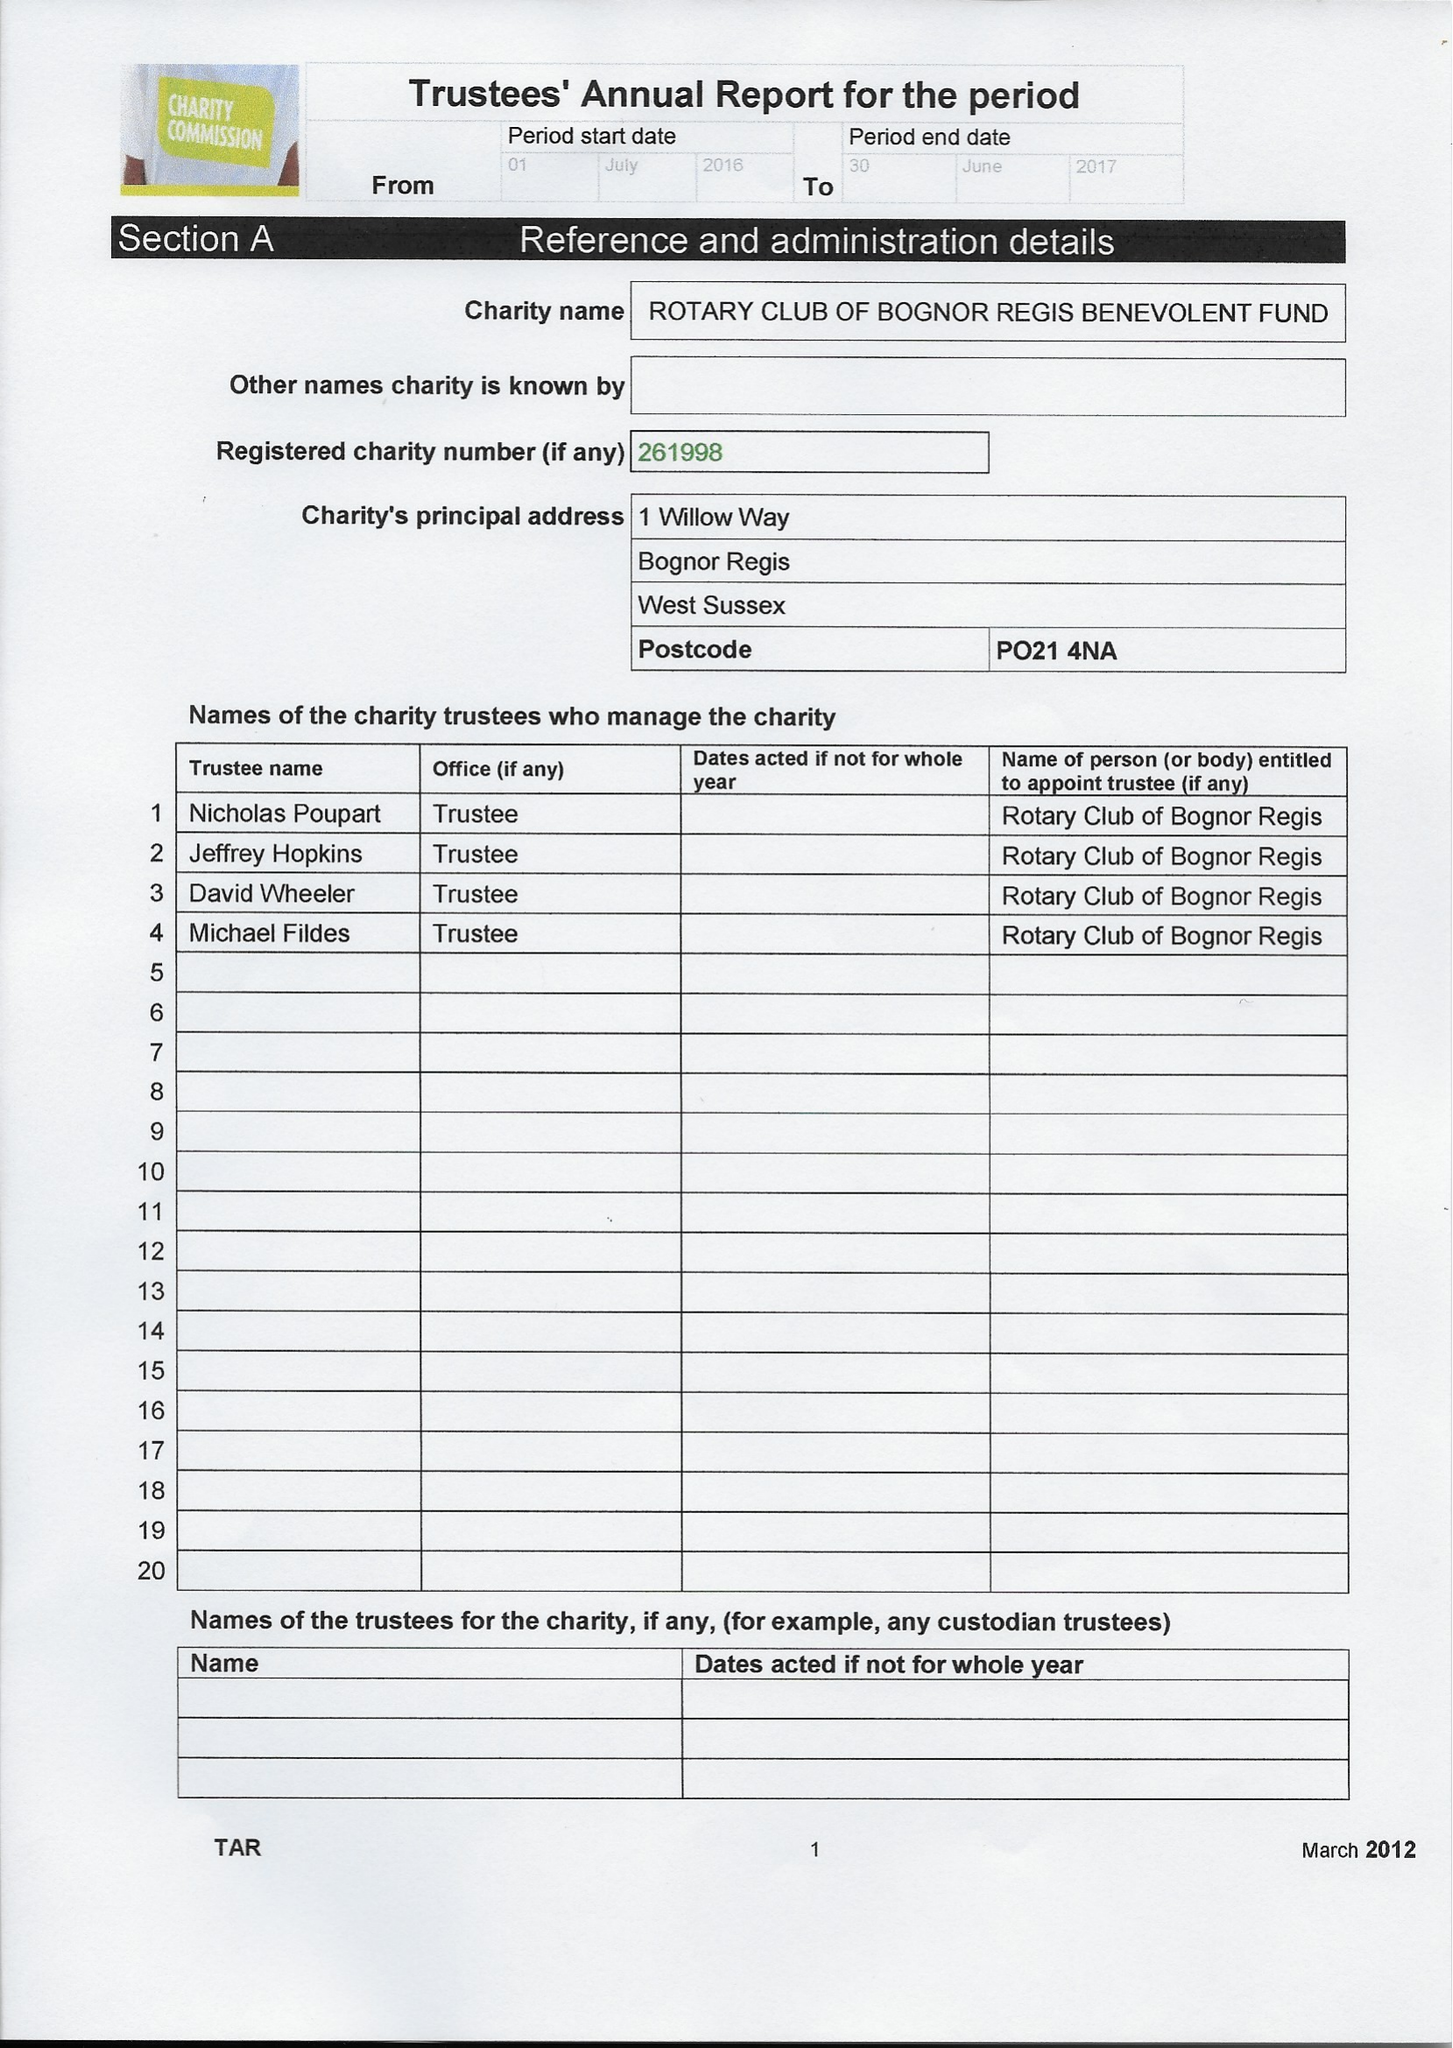What is the value for the address__street_line?
Answer the question using a single word or phrase. 1 WILLOW WAY 